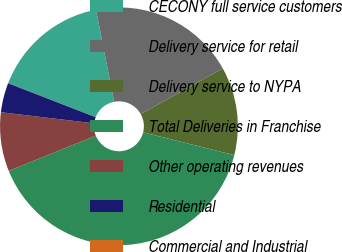Convert chart to OTSL. <chart><loc_0><loc_0><loc_500><loc_500><pie_chart><fcel>CECONY full service customers<fcel>Delivery service for retail<fcel>Delivery service to NYPA<fcel>Total Deliveries in Franchise<fcel>Other operating revenues<fcel>Residential<fcel>Commercial and Industrial<nl><fcel>16.0%<fcel>19.99%<fcel>12.0%<fcel>39.98%<fcel>8.01%<fcel>4.01%<fcel>0.01%<nl></chart> 